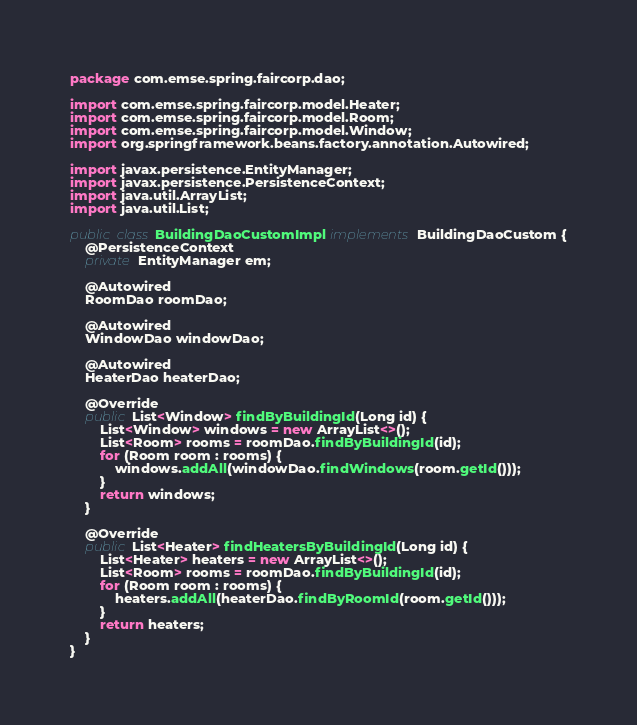<code> <loc_0><loc_0><loc_500><loc_500><_Java_>package com.emse.spring.faircorp.dao;

import com.emse.spring.faircorp.model.Heater;
import com.emse.spring.faircorp.model.Room;
import com.emse.spring.faircorp.model.Window;
import org.springframework.beans.factory.annotation.Autowired;

import javax.persistence.EntityManager;
import javax.persistence.PersistenceContext;
import java.util.ArrayList;
import java.util.List;

public class BuildingDaoCustomImpl implements BuildingDaoCustom {
    @PersistenceContext
    private EntityManager em;

    @Autowired
    RoomDao roomDao;

    @Autowired
    WindowDao windowDao;

    @Autowired
    HeaterDao heaterDao;

    @Override
    public List<Window> findByBuildingId(Long id) {
        List<Window> windows = new ArrayList<>();
        List<Room> rooms = roomDao.findByBuildingId(id);
        for (Room room : rooms) {
            windows.addAll(windowDao.findWindows(room.getId()));
        }
        return windows;
    }

    @Override
    public List<Heater> findHeatersByBuildingId(Long id) {
        List<Heater> heaters = new ArrayList<>();
        List<Room> rooms = roomDao.findByBuildingId(id);
        for (Room room : rooms) {
            heaters.addAll(heaterDao.findByRoomId(room.getId()));
        }
        return heaters;
    }
}
</code> 